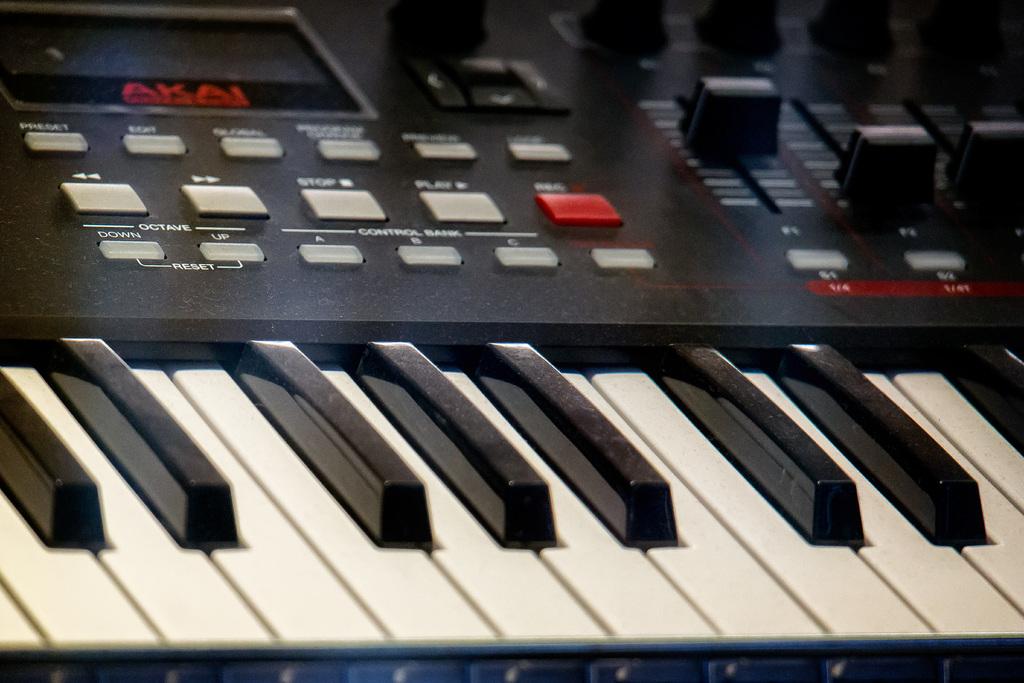What brand of keyboard is this?
Your answer should be compact. Akai. What brand is this keyboard?
Make the answer very short. Akai. 